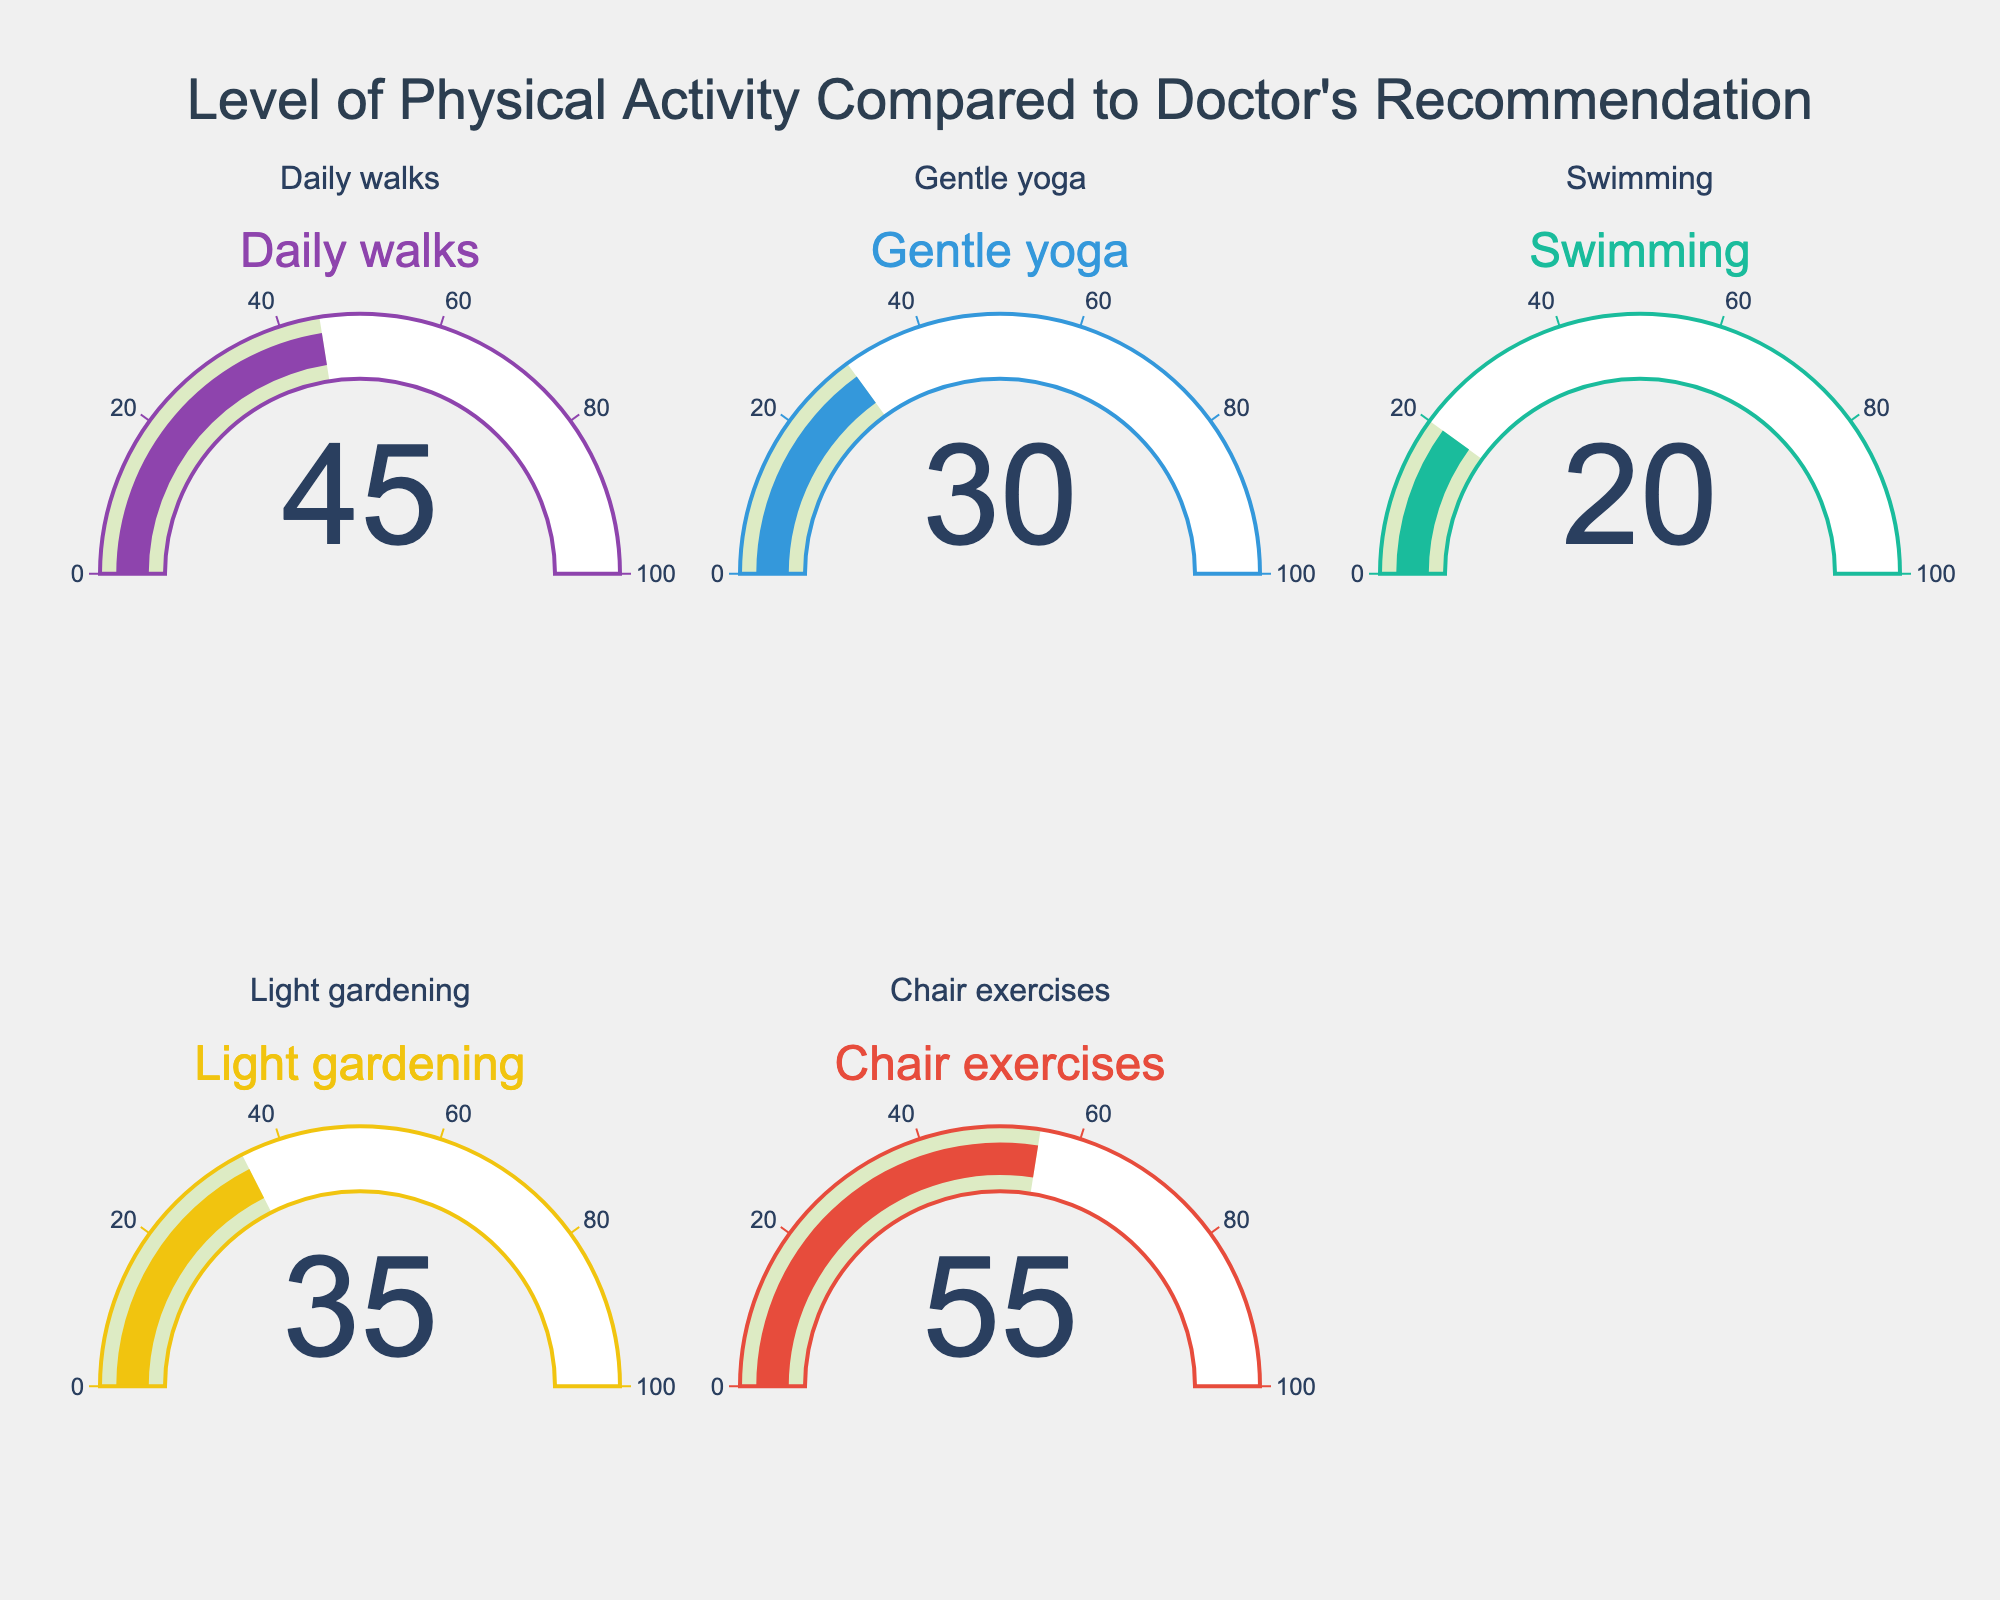Which activity has the lowest percentage compared to the doctor's recommendation? Among all the activities represented in the figure, "Swimming" shows the smallest value of 20%. The value can be directly observed from the gauge chart.
Answer: Swimming Which activity has the highest percentage compared to the doctor's recommendation? "Chair exercises" has the highest value of 55% among the activities shown in the figure. This can be easily seen by looking at the gauge chart.
Answer: Chair exercises How much is the difference in percentages between daily walks and gentle yoga? To find the difference between the percentages for "Daily walks" (45%) and "Gentle yoga" (30%), subtract 30% from 45%, resulting in a difference of 15%.
Answer: 15% What is the average percentage of all the activities compared to the doctor's recommendation? To find the average value, add all the percentages (45% + 30% + 20% + 35% + 55%) which equals 185%, then divide by the number of activities (5). The average is 185% / 5 = 37%.
Answer: 37% Identify the activities that have a percentage lower than 40%. The activities with percentages lower than 40% are "Daily walks" (45%), which is higher than 40%, "Gentle yoga" (30%), "Swimming" (20%), and "Light gardening" (35%). Chair exercises (55%) is higher than 40%. Therefore, the activities below 40% are "Gentle yoga", "Swimming", and "Light gardening".
Answer: Gentle yoga, Swimming, Light gardening Which has a greater percentage, light gardening or daily walks, and by how much? Comparing "Light gardening" (35%) and "Daily walks" (45%), "Daily walks" has a higher percentage. The difference is 45% - 35% = 10%.
Answer: Daily walks, 10% What is the combined percentage of gentle yoga, swimming, and light gardening? Adding the percentages for "Gentle yoga" (30%), "Swimming" (20%), and "Light gardening" (35%) gives a total of 30% + 20% + 35% = 85%.
Answer: 85% If chair exercises and daily walks were combined into one category, what percentage would that be? The percentage for the combined category of "Chair exercises" (55%) and "Daily walks" (45%) would be 55% + 45% = 100%.
Answer: 100% Which pair of activities has the smallest difference in percentage? Comparing the differences, "Gentle yoga" (30%) and "Light gardening" (35%) have a difference of 5%, the smallest difference among the pairs.
Answer: Gentle yoga and Light gardening, 5% 